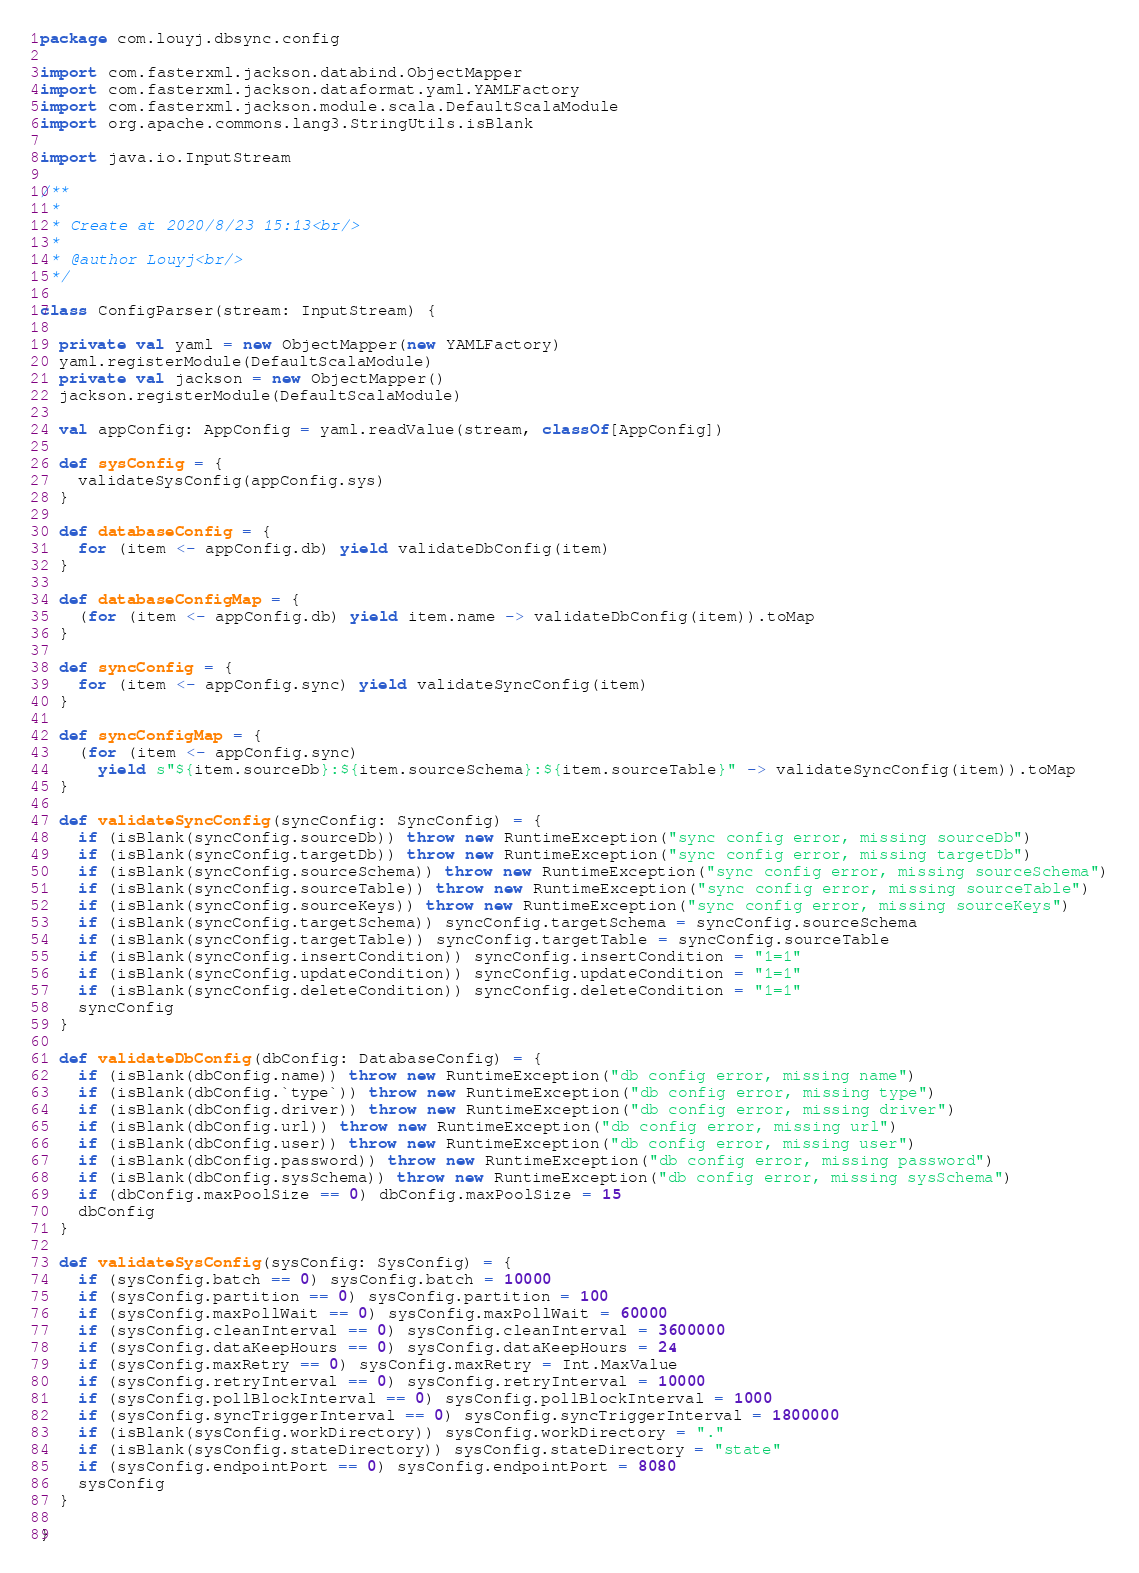<code> <loc_0><loc_0><loc_500><loc_500><_Scala_>package com.louyj.dbsync.config

import com.fasterxml.jackson.databind.ObjectMapper
import com.fasterxml.jackson.dataformat.yaml.YAMLFactory
import com.fasterxml.jackson.module.scala.DefaultScalaModule
import org.apache.commons.lang3.StringUtils.isBlank

import java.io.InputStream

/**
 *
 * Create at 2020/8/23 15:13<br/>
 *
 * @author Louyj<br/>
 */

class ConfigParser(stream: InputStream) {

  private val yaml = new ObjectMapper(new YAMLFactory)
  yaml.registerModule(DefaultScalaModule)
  private val jackson = new ObjectMapper()
  jackson.registerModule(DefaultScalaModule)

  val appConfig: AppConfig = yaml.readValue(stream, classOf[AppConfig])

  def sysConfig = {
    validateSysConfig(appConfig.sys)
  }

  def databaseConfig = {
    for (item <- appConfig.db) yield validateDbConfig(item)
  }

  def databaseConfigMap = {
    (for (item <- appConfig.db) yield item.name -> validateDbConfig(item)).toMap
  }

  def syncConfig = {
    for (item <- appConfig.sync) yield validateSyncConfig(item)
  }

  def syncConfigMap = {
    (for (item <- appConfig.sync)
      yield s"${item.sourceDb}:${item.sourceSchema}:${item.sourceTable}" -> validateSyncConfig(item)).toMap
  }

  def validateSyncConfig(syncConfig: SyncConfig) = {
    if (isBlank(syncConfig.sourceDb)) throw new RuntimeException("sync config error, missing sourceDb")
    if (isBlank(syncConfig.targetDb)) throw new RuntimeException("sync config error, missing targetDb")
    if (isBlank(syncConfig.sourceSchema)) throw new RuntimeException("sync config error, missing sourceSchema")
    if (isBlank(syncConfig.sourceTable)) throw new RuntimeException("sync config error, missing sourceTable")
    if (isBlank(syncConfig.sourceKeys)) throw new RuntimeException("sync config error, missing sourceKeys")
    if (isBlank(syncConfig.targetSchema)) syncConfig.targetSchema = syncConfig.sourceSchema
    if (isBlank(syncConfig.targetTable)) syncConfig.targetTable = syncConfig.sourceTable
    if (isBlank(syncConfig.insertCondition)) syncConfig.insertCondition = "1=1"
    if (isBlank(syncConfig.updateCondition)) syncConfig.updateCondition = "1=1"
    if (isBlank(syncConfig.deleteCondition)) syncConfig.deleteCondition = "1=1"
    syncConfig
  }

  def validateDbConfig(dbConfig: DatabaseConfig) = {
    if (isBlank(dbConfig.name)) throw new RuntimeException("db config error, missing name")
    if (isBlank(dbConfig.`type`)) throw new RuntimeException("db config error, missing type")
    if (isBlank(dbConfig.driver)) throw new RuntimeException("db config error, missing driver")
    if (isBlank(dbConfig.url)) throw new RuntimeException("db config error, missing url")
    if (isBlank(dbConfig.user)) throw new RuntimeException("db config error, missing user")
    if (isBlank(dbConfig.password)) throw new RuntimeException("db config error, missing password")
    if (isBlank(dbConfig.sysSchema)) throw new RuntimeException("db config error, missing sysSchema")
    if (dbConfig.maxPoolSize == 0) dbConfig.maxPoolSize = 15
    dbConfig
  }

  def validateSysConfig(sysConfig: SysConfig) = {
    if (sysConfig.batch == 0) sysConfig.batch = 10000
    if (sysConfig.partition == 0) sysConfig.partition = 100
    if (sysConfig.maxPollWait == 0) sysConfig.maxPollWait = 60000
    if (sysConfig.cleanInterval == 0) sysConfig.cleanInterval = 3600000
    if (sysConfig.dataKeepHours == 0) sysConfig.dataKeepHours = 24
    if (sysConfig.maxRetry == 0) sysConfig.maxRetry = Int.MaxValue
    if (sysConfig.retryInterval == 0) sysConfig.retryInterval = 10000
    if (sysConfig.pollBlockInterval == 0) sysConfig.pollBlockInterval = 1000
    if (sysConfig.syncTriggerInterval == 0) sysConfig.syncTriggerInterval = 1800000
    if (isBlank(sysConfig.workDirectory)) sysConfig.workDirectory = "."
    if (isBlank(sysConfig.stateDirectory)) sysConfig.stateDirectory = "state"
    if (sysConfig.endpointPort == 0) sysConfig.endpointPort = 8080
    sysConfig
  }

}
</code> 